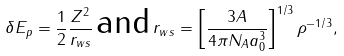Convert formula to latex. <formula><loc_0><loc_0><loc_500><loc_500>\delta E _ { p } = \frac { 1 } { 2 } \frac { Z ^ { 2 } } { r _ { w s } } \, \text {and} \, r _ { w s } = \left [ \frac { 3 A } { 4 \pi N _ { A } a _ { 0 } ^ { 3 } } \right ] ^ { 1 / 3 } \rho ^ { - 1 / 3 } ,</formula> 